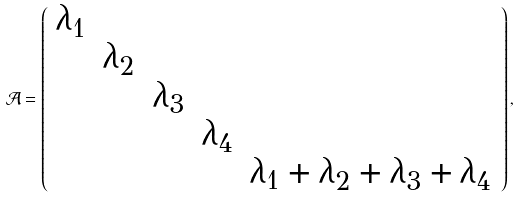Convert formula to latex. <formula><loc_0><loc_0><loc_500><loc_500>\mathcal { A } = \left ( \begin{array} { c c c c c c c c c c } \lambda _ { 1 } & & & & \\ & \lambda _ { 2 } & & & \\ & & \lambda _ { 3 } & & \\ & & & \lambda _ { 4 } & \\ & & & & \lambda _ { 1 } + \lambda _ { 2 } + \lambda _ { 3 } + \lambda _ { 4 } \\ \end{array} \right ) ,</formula> 